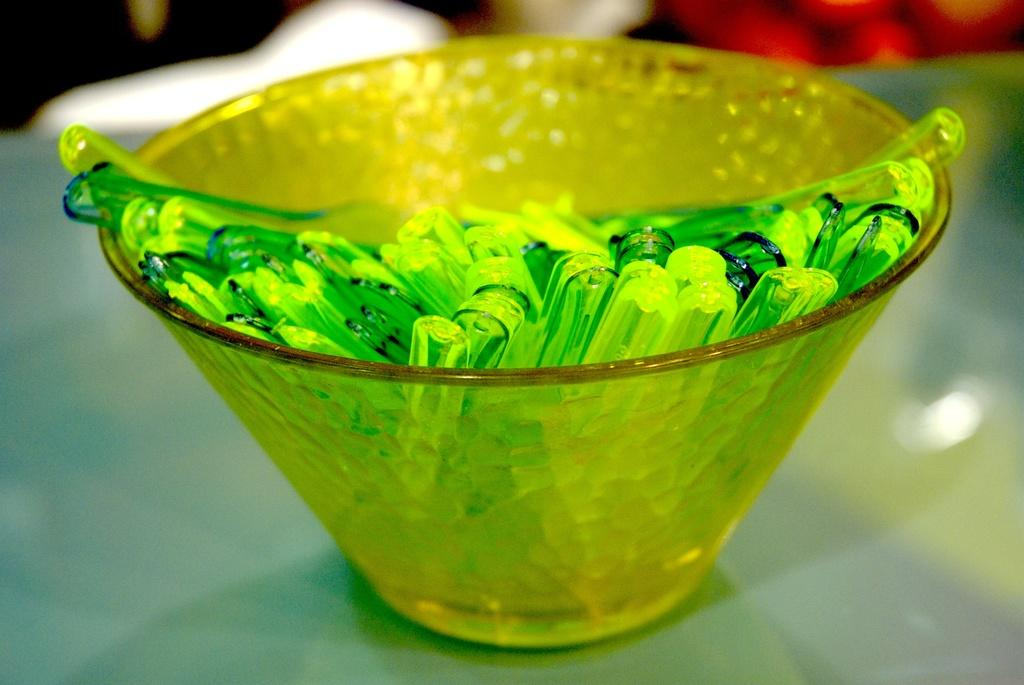What is in the bowl that is visible in the image? There are objects in the bowl that look like spoons in the image. Where is the bowl located in the image? The bowl is placed on a table in the image. Can you describe the background of the image? The background of the image is blurry. What type of lumber is being harvested in the background of the image? There is no lumber or any indication of harvesting in the image; it only features a bowl with objects that look like spoons on a table with a blurry background. 